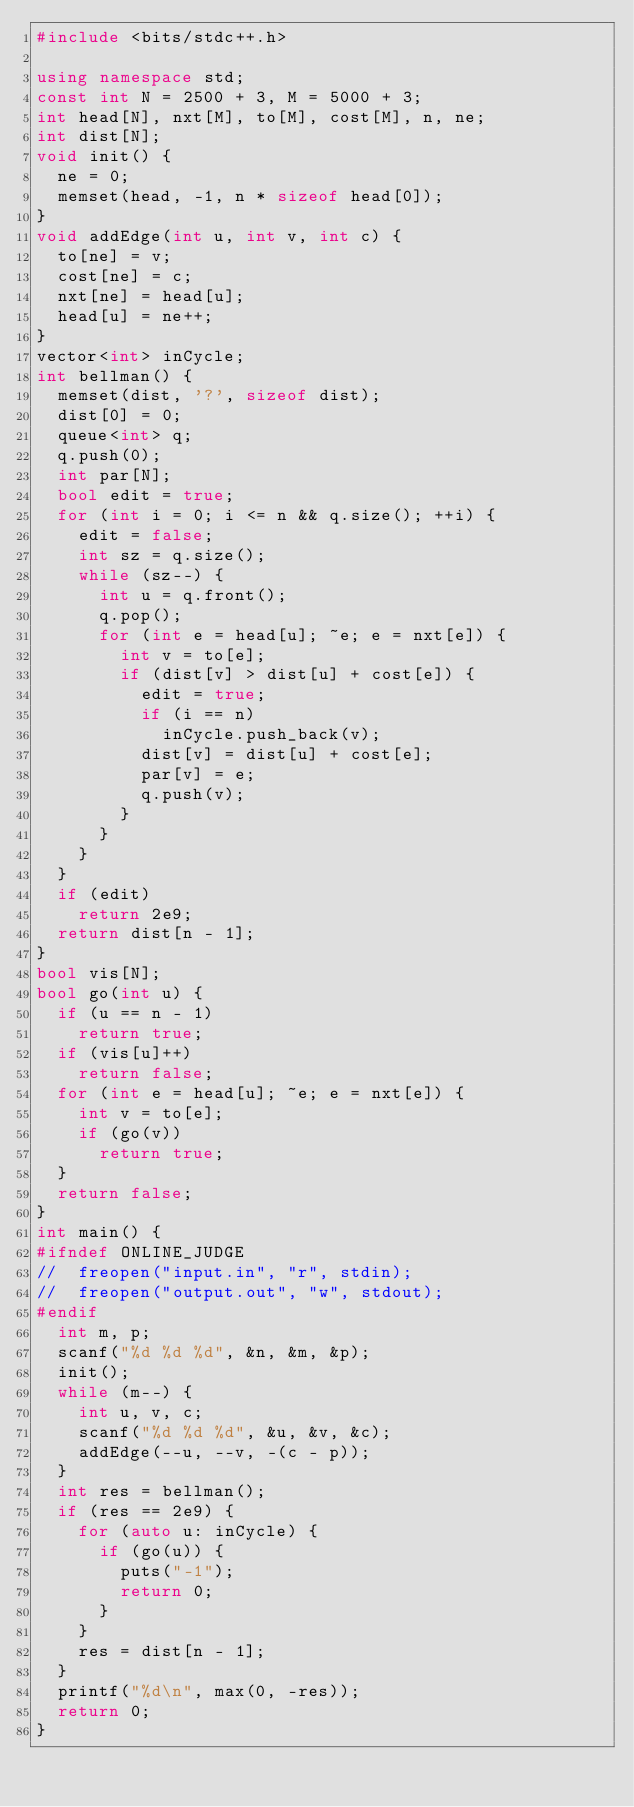Convert code to text. <code><loc_0><loc_0><loc_500><loc_500><_C++_>#include <bits/stdc++.h>

using namespace std;
const int N = 2500 + 3, M = 5000 + 3;
int head[N], nxt[M], to[M], cost[M], n, ne;
int dist[N];
void init() {
	ne = 0;
	memset(head, -1, n * sizeof head[0]);
}
void addEdge(int u, int v, int c) {
	to[ne] = v;
	cost[ne] = c;
	nxt[ne] = head[u];
	head[u] = ne++;
}
vector<int> inCycle;
int bellman() {
	memset(dist, '?', sizeof dist);
	dist[0] = 0;
	queue<int> q;
	q.push(0);
	int par[N];
	bool edit = true;
	for (int i = 0; i <= n && q.size(); ++i) {
		edit = false;
		int sz = q.size();
		while (sz--) {
			int u = q.front();
			q.pop();
			for (int e = head[u]; ~e; e = nxt[e]) {
				int v = to[e];
				if (dist[v] > dist[u] + cost[e]) {
					edit = true;
					if (i == n)
						inCycle.push_back(v);
					dist[v] = dist[u] + cost[e];
					par[v] = e;
					q.push(v);
				}
			}
		}
	}
	if (edit)
		return 2e9;
	return dist[n - 1];
}
bool vis[N];
bool go(int u) {
	if (u == n - 1)
		return true;
	if (vis[u]++)
		return false;
	for (int e = head[u]; ~e; e = nxt[e]) {
		int v = to[e];
		if (go(v))
			return true;
	}
	return false;
}
int main() {
#ifndef ONLINE_JUDGE
//	freopen("input.in", "r", stdin);
//	freopen("output.out", "w", stdout);
#endif
	int m, p;
	scanf("%d %d %d", &n, &m, &p);
	init();
	while (m--) {
		int u, v, c;
		scanf("%d %d %d", &u, &v, &c);
		addEdge(--u, --v, -(c - p));
	}
	int res = bellman();
	if (res == 2e9) {
		for (auto u: inCycle) {
			if (go(u)) {
				puts("-1");
				return 0;
			}
		}
		res = dist[n - 1];
	}
	printf("%d\n", max(0, -res));
	return 0;
}
</code> 